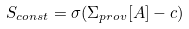<formula> <loc_0><loc_0><loc_500><loc_500>S _ { c o n s t } = \sigma ( \Sigma _ { p r o v } [ A ] - c )</formula> 